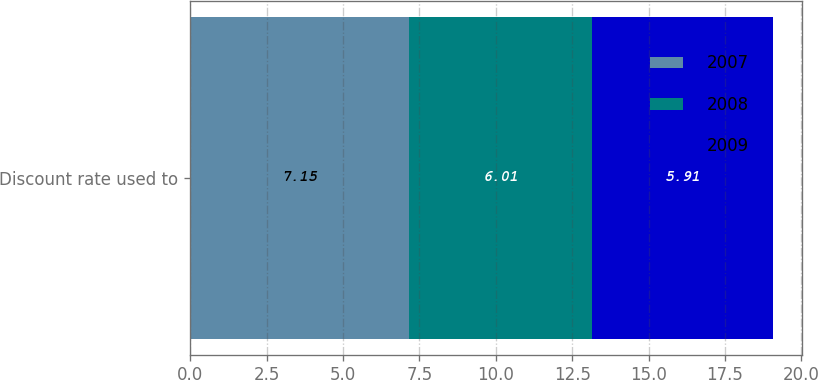<chart> <loc_0><loc_0><loc_500><loc_500><stacked_bar_chart><ecel><fcel>Discount rate used to<nl><fcel>2007<fcel>7.15<nl><fcel>2008<fcel>6.01<nl><fcel>2009<fcel>5.91<nl></chart> 